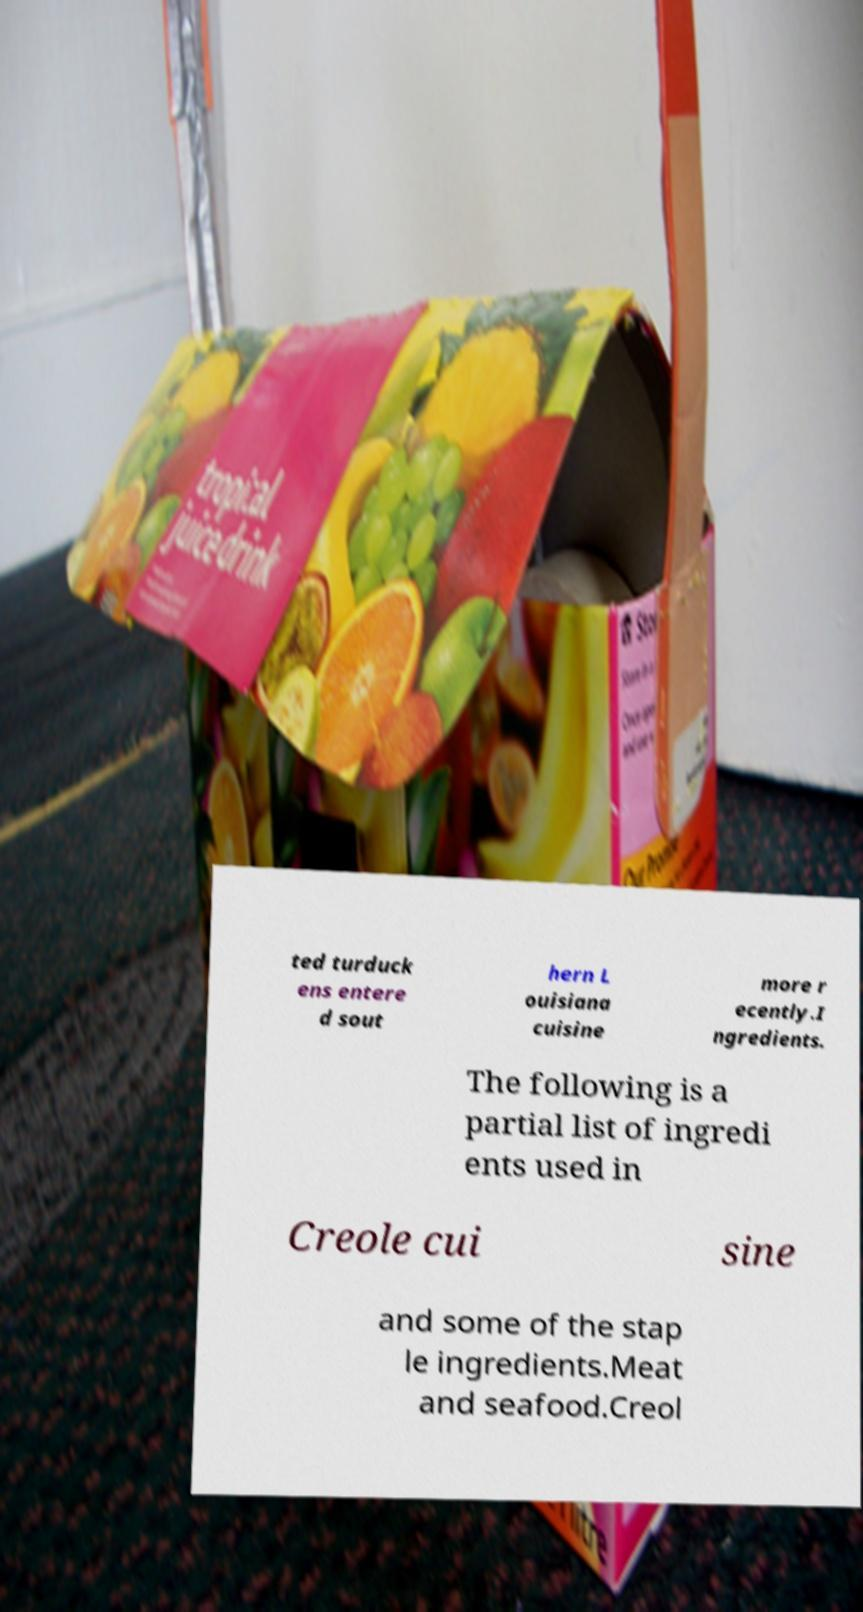Could you assist in decoding the text presented in this image and type it out clearly? ted turduck ens entere d sout hern L ouisiana cuisine more r ecently.I ngredients. The following is a partial list of ingredi ents used in Creole cui sine and some of the stap le ingredients.Meat and seafood.Creol 